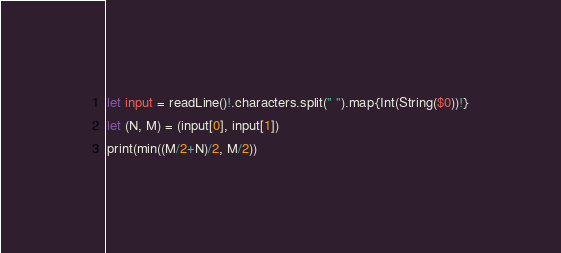<code> <loc_0><loc_0><loc_500><loc_500><_Swift_>let input = readLine()!.characters.split(" ").map{Int(String($0))!}
let (N, M) = (input[0], input[1])
print(min((M/2+N)/2, M/2))</code> 